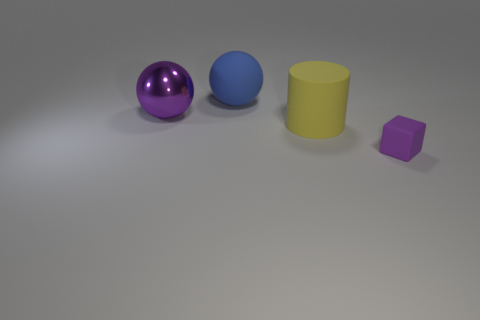The large purple metallic object has what shape?
Ensure brevity in your answer.  Sphere. What number of things are either rubber cubes or big metallic things behind the large yellow thing?
Offer a very short reply. 2. Does the matte object that is in front of the yellow matte thing have the same color as the large shiny object?
Keep it short and to the point. Yes. What color is the rubber thing that is both in front of the matte sphere and behind the rubber cube?
Give a very brief answer. Yellow. What is the big object that is on the right side of the large blue sphere made of?
Provide a succinct answer. Rubber. How big is the blue matte ball?
Your response must be concise. Large. How many blue objects are either matte things or tiny cubes?
Your response must be concise. 1. What is the size of the purple object that is to the left of the sphere behind the purple shiny ball?
Provide a short and direct response. Large. There is a large metal thing; is it the same color as the big thing on the right side of the large blue ball?
Keep it short and to the point. No. What number of other things are made of the same material as the blue sphere?
Ensure brevity in your answer.  2. 